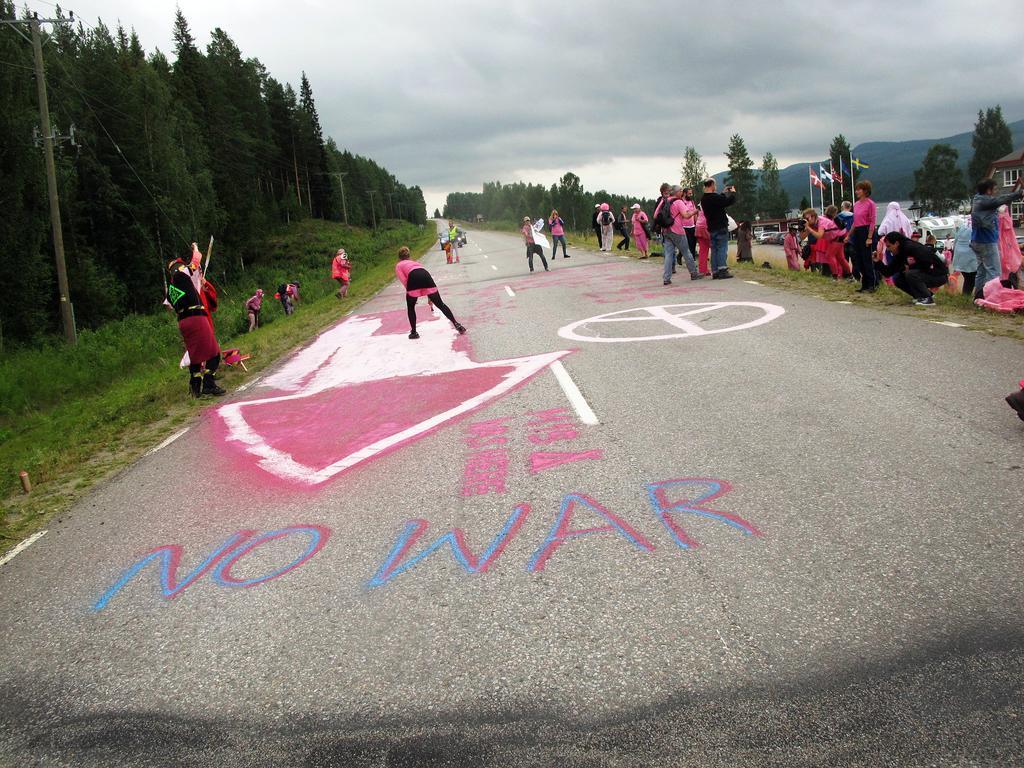Describe this image in one or two sentences. In the center of the image there are people painting on the road. On both left and right side of the image there are people standing on the grass. In the background of the image there are flags, buildings, trees, mountains and sky. 